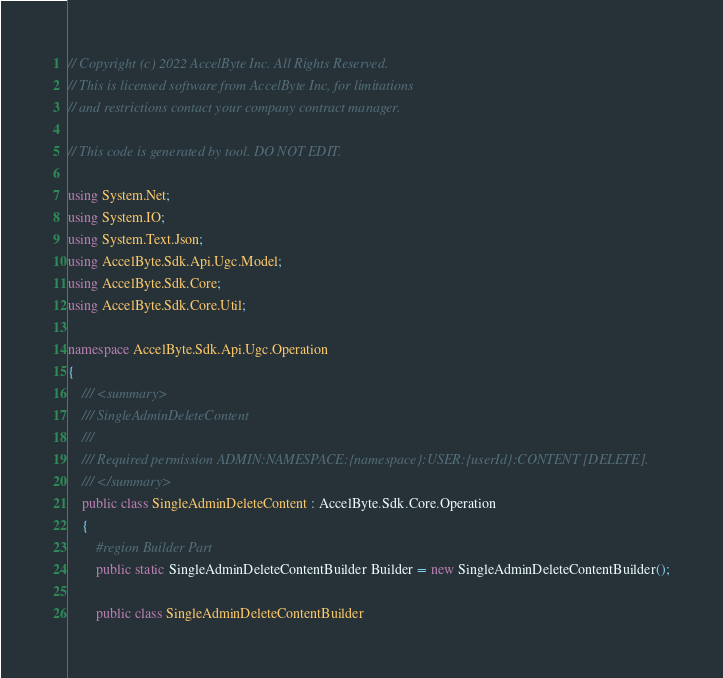Convert code to text. <code><loc_0><loc_0><loc_500><loc_500><_C#_>// Copyright (c) 2022 AccelByte Inc. All Rights Reserved.
// This is licensed software from AccelByte Inc, for limitations
// and restrictions contact your company contract manager.

// This code is generated by tool. DO NOT EDIT.

using System.Net;
using System.IO;
using System.Text.Json;
using AccelByte.Sdk.Api.Ugc.Model;
using AccelByte.Sdk.Core;
using AccelByte.Sdk.Core.Util;

namespace AccelByte.Sdk.Api.Ugc.Operation
{
    /// <summary>
    /// SingleAdminDeleteContent
    ///
    /// Required permission ADMIN:NAMESPACE:{namespace}:USER:{userId}:CONTENT [DELETE].
    /// </summary>
    public class SingleAdminDeleteContent : AccelByte.Sdk.Core.Operation
    {
        #region Builder Part
        public static SingleAdminDeleteContentBuilder Builder = new SingleAdminDeleteContentBuilder();

        public class SingleAdminDeleteContentBuilder</code> 